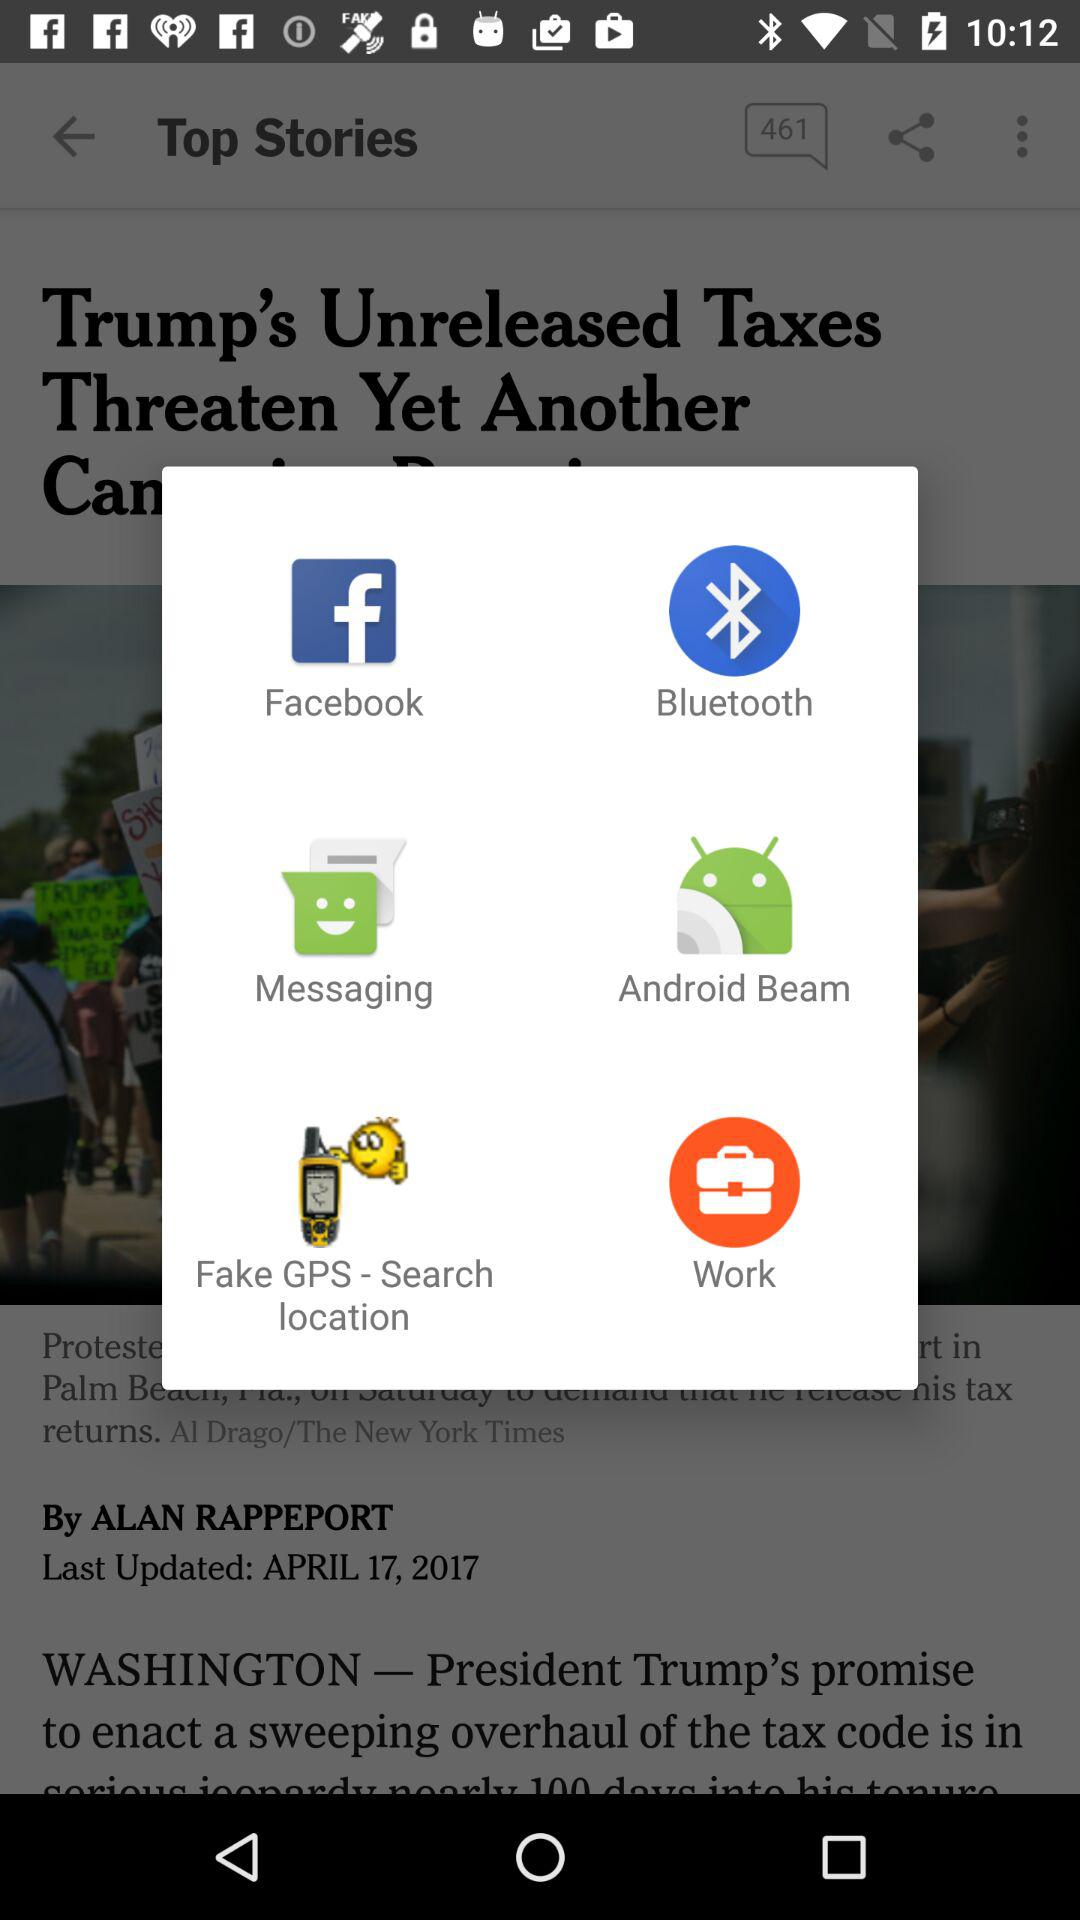What is the name of the article's author? The article's author is Alan Rappeport. 